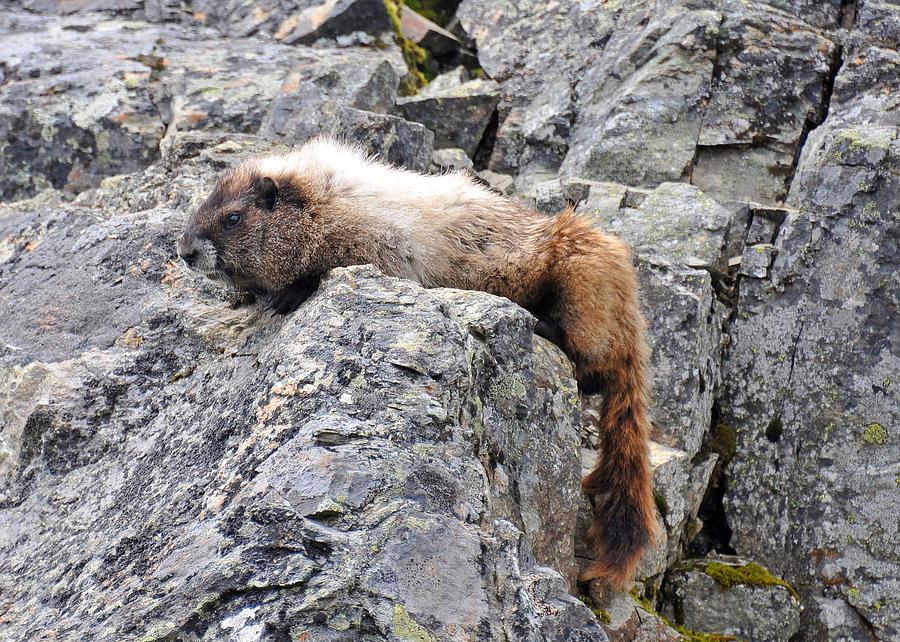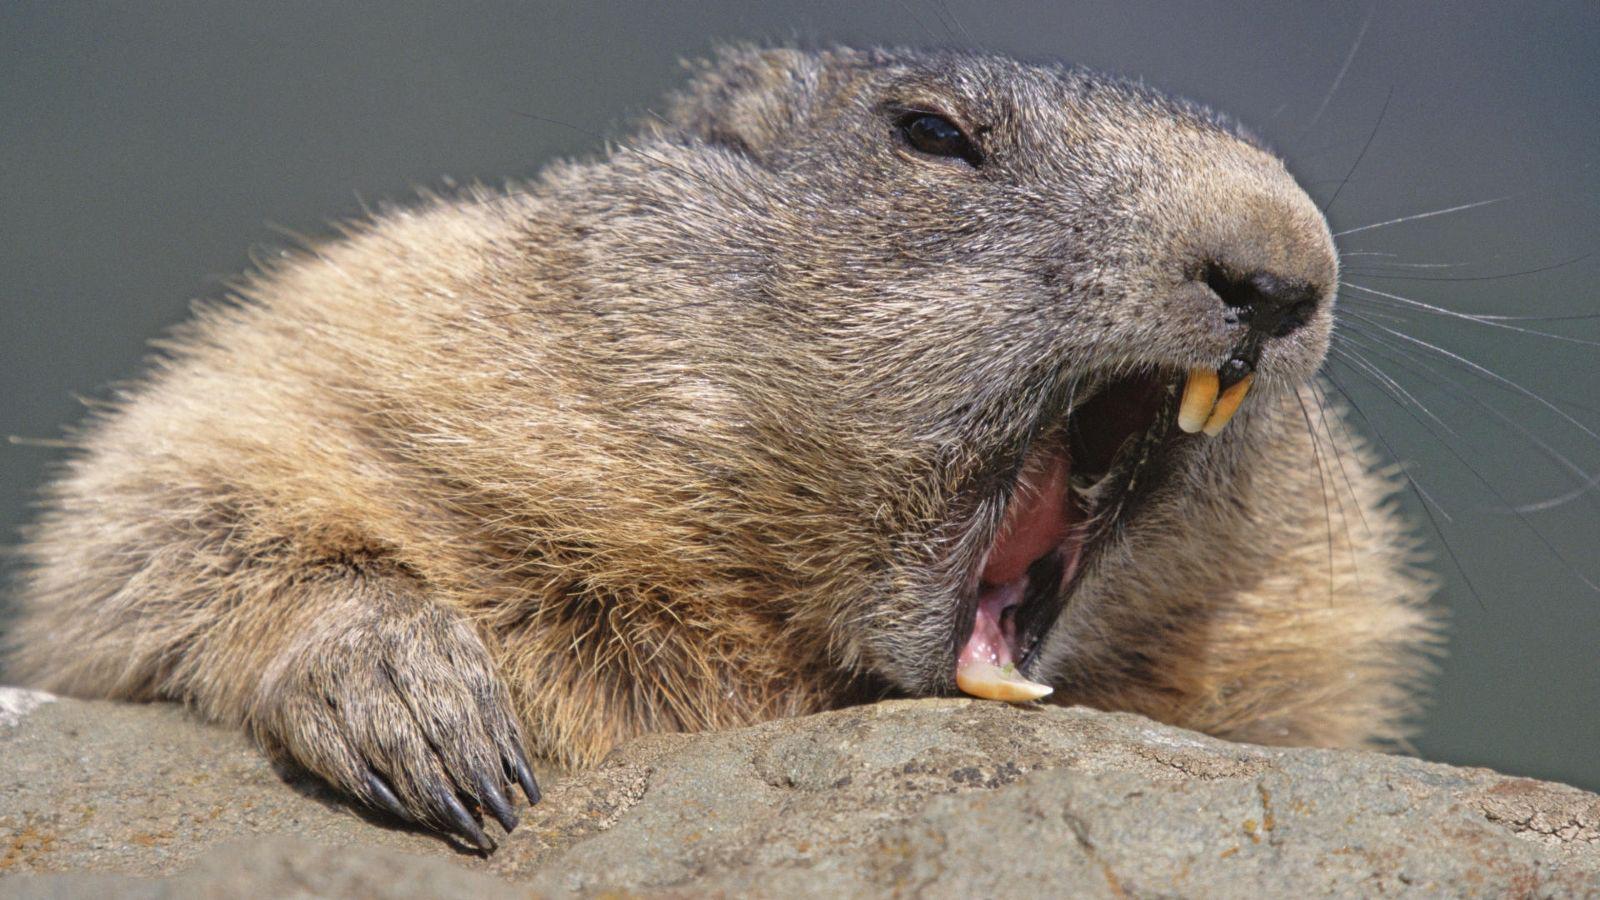The first image is the image on the left, the second image is the image on the right. Analyze the images presented: Is the assertion "One image shows a rodent-type animal standing upright with front paws clasped together." valid? Answer yes or no. No. 